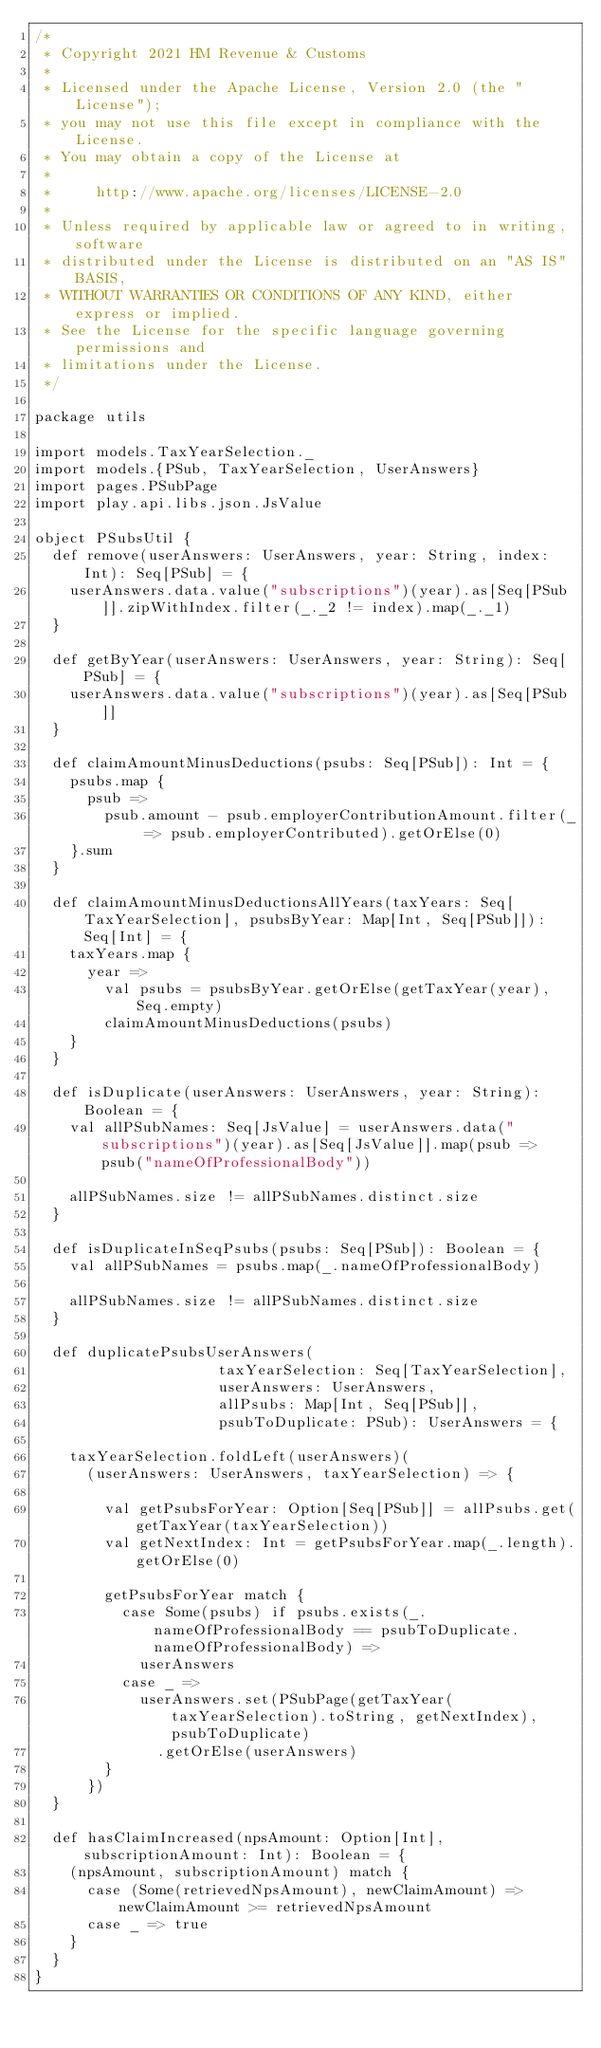<code> <loc_0><loc_0><loc_500><loc_500><_Scala_>/*
 * Copyright 2021 HM Revenue & Customs
 *
 * Licensed under the Apache License, Version 2.0 (the "License");
 * you may not use this file except in compliance with the License.
 * You may obtain a copy of the License at
 *
 *     http://www.apache.org/licenses/LICENSE-2.0
 *
 * Unless required by applicable law or agreed to in writing, software
 * distributed under the License is distributed on an "AS IS" BASIS,
 * WITHOUT WARRANTIES OR CONDITIONS OF ANY KIND, either express or implied.
 * See the License for the specific language governing permissions and
 * limitations under the License.
 */

package utils

import models.TaxYearSelection._
import models.{PSub, TaxYearSelection, UserAnswers}
import pages.PSubPage
import play.api.libs.json.JsValue

object PSubsUtil {
  def remove(userAnswers: UserAnswers, year: String, index: Int): Seq[PSub] = {
    userAnswers.data.value("subscriptions")(year).as[Seq[PSub]].zipWithIndex.filter(_._2 != index).map(_._1)
  }

  def getByYear(userAnswers: UserAnswers, year: String): Seq[PSub] = {
    userAnswers.data.value("subscriptions")(year).as[Seq[PSub]]
  }

  def claimAmountMinusDeductions(psubs: Seq[PSub]): Int = {
    psubs.map {
      psub =>
        psub.amount - psub.employerContributionAmount.filter(_ => psub.employerContributed).getOrElse(0)
    }.sum
  }

  def claimAmountMinusDeductionsAllYears(taxYears: Seq[TaxYearSelection], psubsByYear: Map[Int, Seq[PSub]]): Seq[Int] = {
    taxYears.map {
      year =>
        val psubs = psubsByYear.getOrElse(getTaxYear(year), Seq.empty)
        claimAmountMinusDeductions(psubs)
    }
  }

  def isDuplicate(userAnswers: UserAnswers, year: String): Boolean = {
    val allPSubNames: Seq[JsValue] = userAnswers.data("subscriptions")(year).as[Seq[JsValue]].map(psub => psub("nameOfProfessionalBody"))

    allPSubNames.size != allPSubNames.distinct.size
  }

  def isDuplicateInSeqPsubs(psubs: Seq[PSub]): Boolean = {
    val allPSubNames = psubs.map(_.nameOfProfessionalBody)

    allPSubNames.size != allPSubNames.distinct.size
  }

  def duplicatePsubsUserAnswers(
                     taxYearSelection: Seq[TaxYearSelection],
                     userAnswers: UserAnswers,
                     allPsubs: Map[Int, Seq[PSub]],
                     psubToDuplicate: PSub): UserAnswers = {

    taxYearSelection.foldLeft(userAnswers)(
      (userAnswers: UserAnswers, taxYearSelection) => {

        val getPsubsForYear: Option[Seq[PSub]] = allPsubs.get(getTaxYear(taxYearSelection))
        val getNextIndex: Int = getPsubsForYear.map(_.length).getOrElse(0)

        getPsubsForYear match {
          case Some(psubs) if psubs.exists(_.nameOfProfessionalBody == psubToDuplicate.nameOfProfessionalBody) =>
            userAnswers
          case _ =>
            userAnswers.set(PSubPage(getTaxYear(taxYearSelection).toString, getNextIndex), psubToDuplicate)
              .getOrElse(userAnswers)
        }
      })
  }

  def hasClaimIncreased(npsAmount: Option[Int], subscriptionAmount: Int): Boolean = {
    (npsAmount, subscriptionAmount) match {
      case (Some(retrievedNpsAmount), newClaimAmount) => newClaimAmount >= retrievedNpsAmount
      case _ => true
    }
  }
}
</code> 